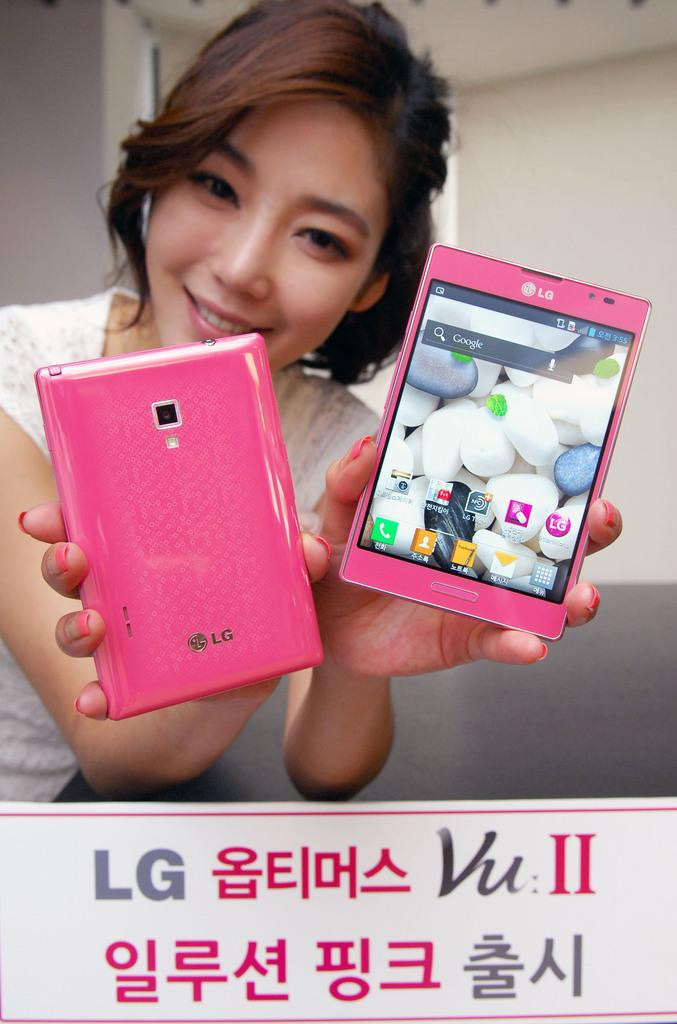<image>
Render a clear and concise summary of the photo. a girl is posing for a picture with two LG branded pink phones with korean text on the bottom. 